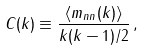<formula> <loc_0><loc_0><loc_500><loc_500>C ( k ) \equiv \frac { \langle m _ { n n } ( k ) \rangle } { k ( k - 1 ) / 2 } \, ,</formula> 